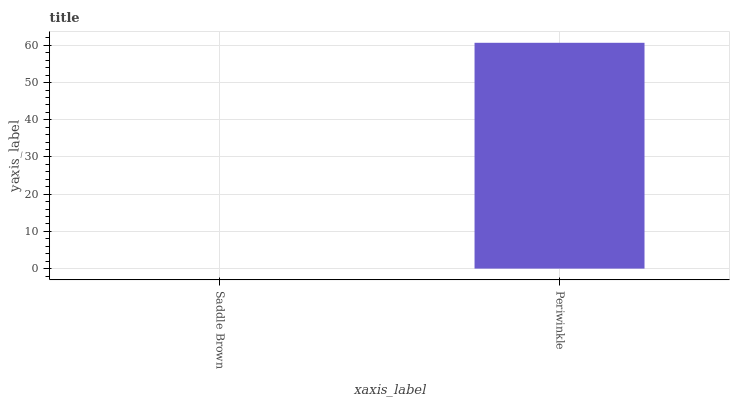Is Saddle Brown the minimum?
Answer yes or no. Yes. Is Periwinkle the maximum?
Answer yes or no. Yes. Is Periwinkle the minimum?
Answer yes or no. No. Is Periwinkle greater than Saddle Brown?
Answer yes or no. Yes. Is Saddle Brown less than Periwinkle?
Answer yes or no. Yes. Is Saddle Brown greater than Periwinkle?
Answer yes or no. No. Is Periwinkle less than Saddle Brown?
Answer yes or no. No. Is Periwinkle the high median?
Answer yes or no. Yes. Is Saddle Brown the low median?
Answer yes or no. Yes. Is Saddle Brown the high median?
Answer yes or no. No. Is Periwinkle the low median?
Answer yes or no. No. 